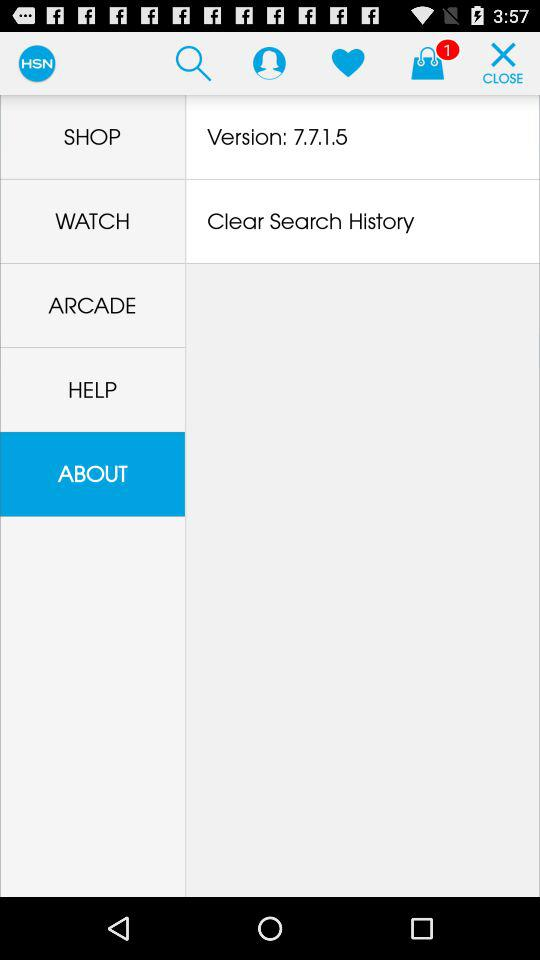How many items are in the bag? There is 1 item in the bag. 